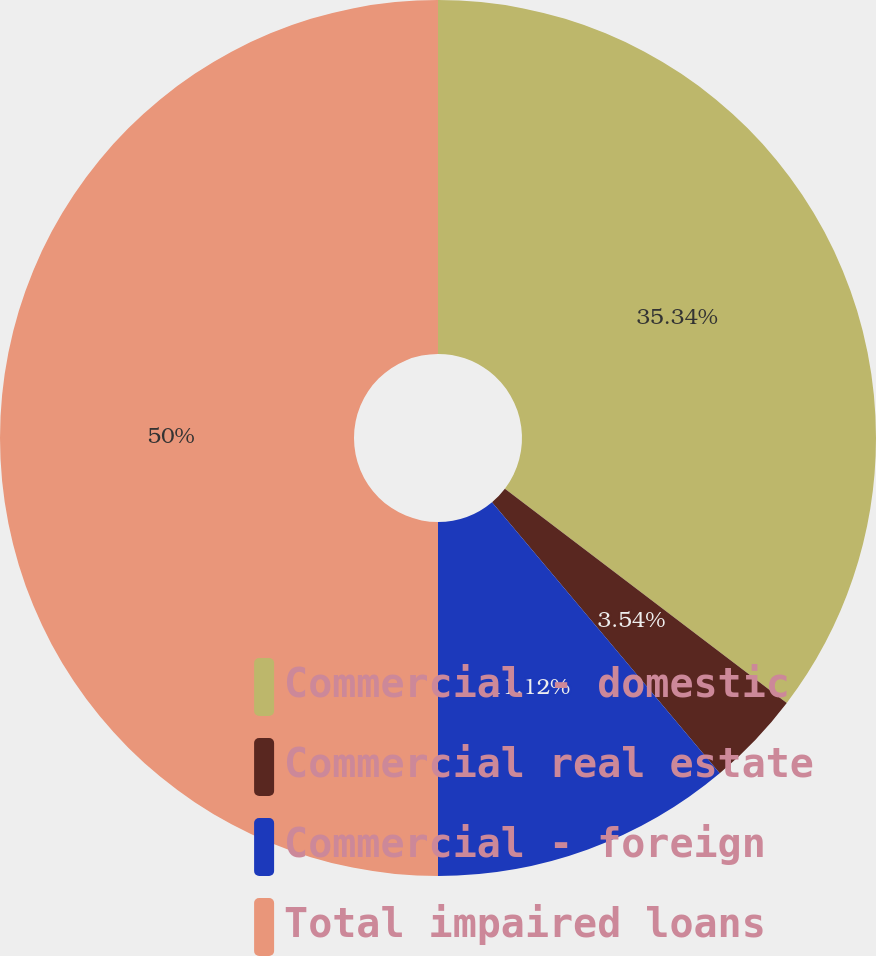<chart> <loc_0><loc_0><loc_500><loc_500><pie_chart><fcel>Commercial - domestic<fcel>Commercial real estate<fcel>Commercial - foreign<fcel>Total impaired loans<nl><fcel>35.34%<fcel>3.54%<fcel>11.12%<fcel>50.0%<nl></chart> 